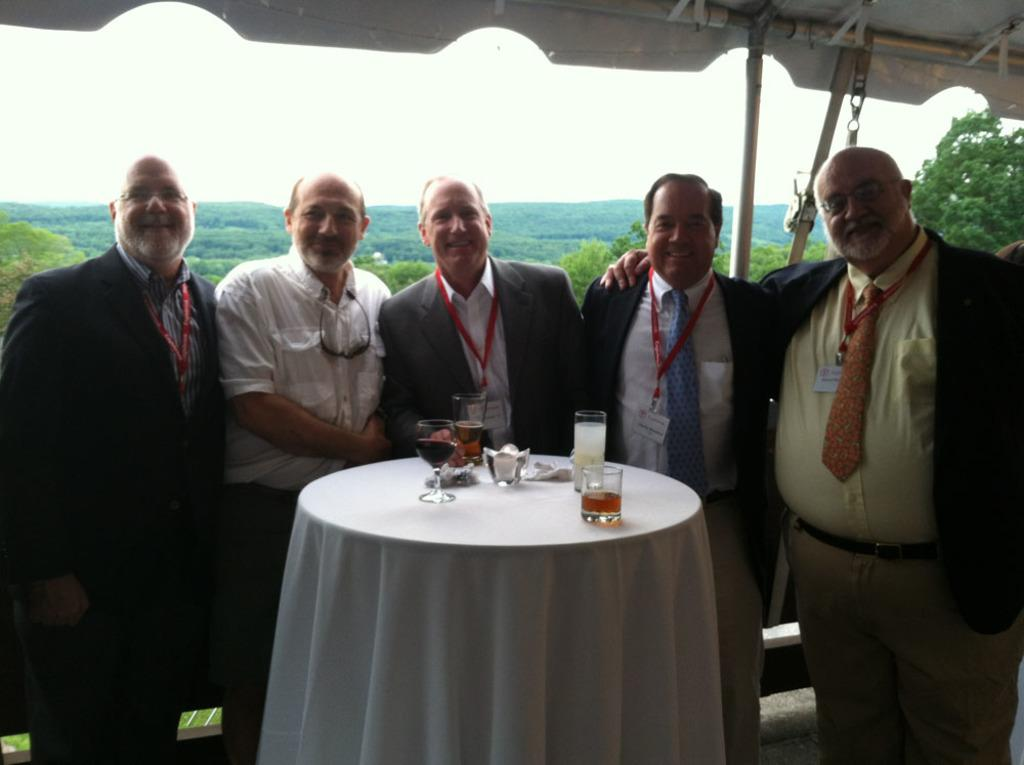How many people are in the image? There is a group of five men in the image. What are the men doing in the image? The men are standing at a table. What objects can be seen on the table? There are glasses on the table. What is the current weather condition in the image? The provided facts do not mention any weather conditions, so it cannot be determined from the image. 